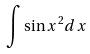<formula> <loc_0><loc_0><loc_500><loc_500>\int \sin x ^ { 2 } d x</formula> 